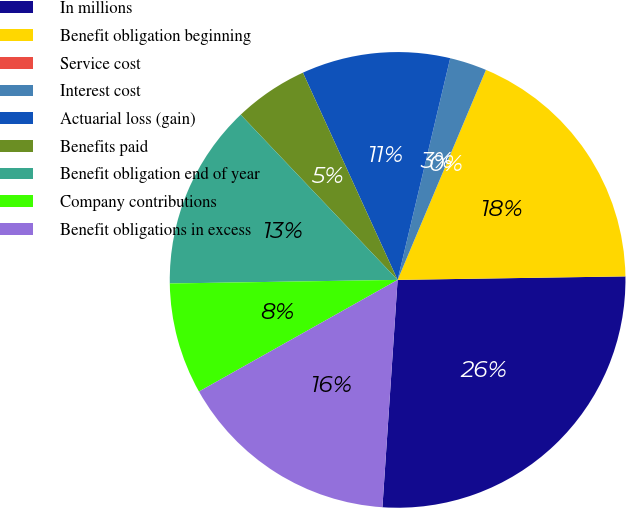Convert chart to OTSL. <chart><loc_0><loc_0><loc_500><loc_500><pie_chart><fcel>In millions<fcel>Benefit obligation beginning<fcel>Service cost<fcel>Interest cost<fcel>Actuarial loss (gain)<fcel>Benefits paid<fcel>Benefit obligation end of year<fcel>Company contributions<fcel>Benefit obligations in excess<nl><fcel>26.31%<fcel>18.42%<fcel>0.0%<fcel>2.63%<fcel>10.53%<fcel>5.27%<fcel>13.16%<fcel>7.9%<fcel>15.79%<nl></chart> 